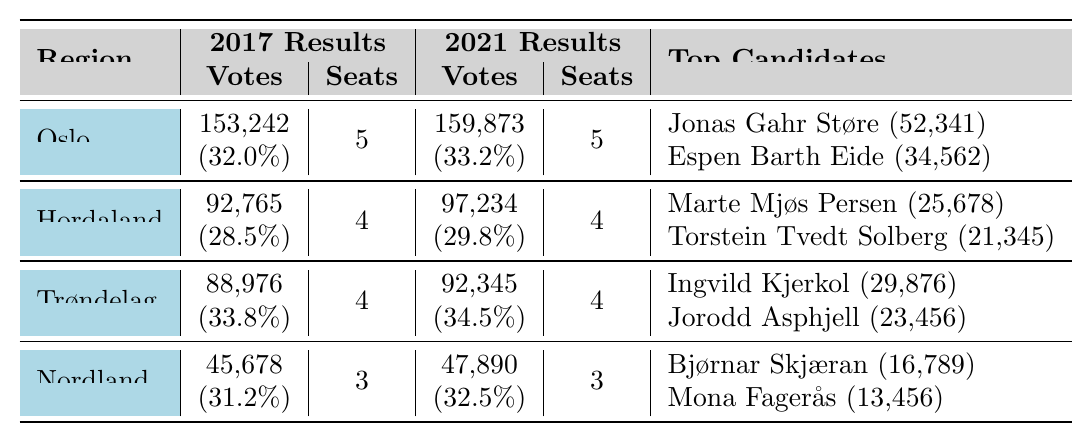What was the total number of votes for the Labour Party in Oslo in 2021? The table shows that the total number of votes for Oslo in 2021 was 159,873.
Answer: 159,873 How many seats did the Labour Party win in Trøndelag in 2017? According to the table, the Labour Party won 4 seats in Trøndelag in 2017.
Answer: 4 Which candidate received the highest individual votes in Hordaland in 2021? The table indicates that Marte Mjøs Persen had the highest individual votes in Hordaland in 2021 with 25,678 votes.
Answer: Marte Mjøs Persen What is the percentage increase in total votes for the Labour Party in Nordland from 2017 to 2021? The total votes in Nordland were 45,678 in 2017 and 47,890 in 2021. The increase is 47,890 - 45,678 = 2,212. The percentage increase is (2,212/45,678) * 100, which is approximately 4.84%.
Answer: Approximately 4.84% Did the Labour Party win the same number of seats in Hordaland in both 2017 and 2021? The table shows that the Labour Party won 4 seats in Hordaland for both election years, indicating the same number of seats were won.
Answer: Yes What is the total number of individual votes for the top two candidates in Oslo in 2021? The table shows that Jonas Gahr Støre received 52,341 votes and Espen Barth Eide received 34,562 votes in 2021. Adding these together gives 52,341 + 34,562 = 86,903 votes.
Answer: 86,903 How did the Labour Party's percentage of votes in Trøndelag change from 2017 to 2021? In Trøndelag, the percentage changed from 33.8% in 2017 to 34.5% in 2021. The difference is 34.5% - 33.8% = 0.7%.
Answer: Increased by 0.7% Identify the region with the lowest total votes in 2017 and state the votes. The table indicates that Nordland had the lowest total votes in 2017 with 45,678 votes.
Answer: Nordland, 45,678 Which candidate had the lowest number of votes among the top candidates in Hordaland in 2017? The table shows that Marte Mjøs Persen received 19,876 votes and Jette Christensen received 23,456 in 2017, making Marte Mjøs Persen the one with the lowest number of votes.
Answer: Marte Mjøs Persen What was the average percentage of votes received by the Labour Party across all mentioned regions in 2021? The percentages in 2021 are 33.2% (Oslo), 29.8% (Hordaland), 34.5% (Trøndelag), and 32.5% (Nordland). The average is (33.2 + 29.8 + 34.5 + 32.5) / 4 = 32.5%.
Answer: 32.5% 